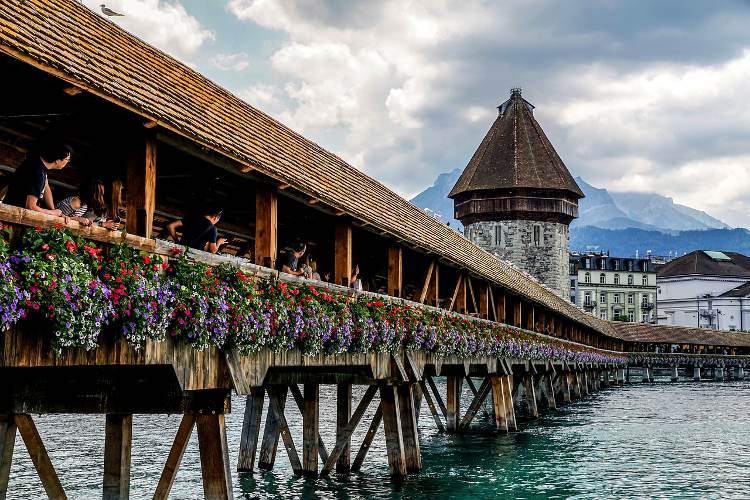Let's imagine this bridge is a portal to another world. What kind of world would it lead to? Stepping onto the Chapel Bridge and traversing its length might bring you to a magnificent, enchanted world. On the other side, you’d find yourself in a realm where time stood still and the rich history of Lucerne melded with magical realism. This world would feature picturesque villages nestled among towering mountain ranges, shimmering with an ethereal glow. Every stone of this parallel universe would tell a story, and ancient trees along the paths would whisper forgotten legends. Creatures of myth, like dragons and faeries, would inhabit the forests, engaging in harmonious coexistence with the people. The air would be filled with melodies of enchantment played by elvish minstrels, and every sunset would paint the sky with colors unseen by human eyes. At the heart of this realm, a castle made of crystal and light would rise, symbolizing the unity and timelessness of this magical world reachable only by the legendary Chapel Bridge. 